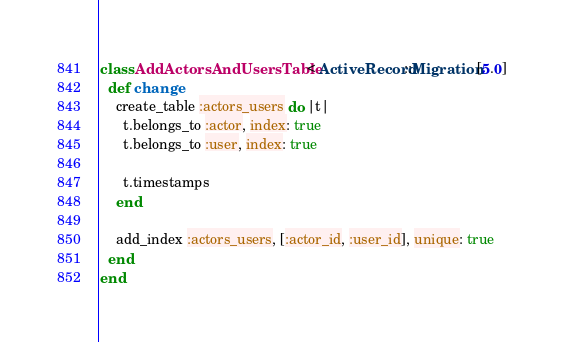<code> <loc_0><loc_0><loc_500><loc_500><_Ruby_>class AddActorsAndUsersTable < ActiveRecord::Migration[5.0]
  def change
    create_table :actors_users do |t|
      t.belongs_to :actor, index: true
      t.belongs_to :user, index: true

      t.timestamps
    end

    add_index :actors_users, [:actor_id, :user_id], unique: true
  end
end
</code> 